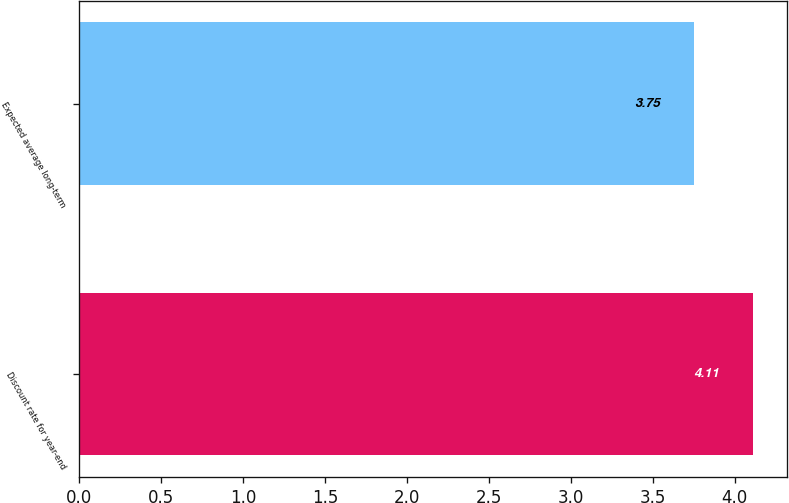Convert chart to OTSL. <chart><loc_0><loc_0><loc_500><loc_500><bar_chart><fcel>Discount rate for year-end<fcel>Expected average long-term<nl><fcel>4.11<fcel>3.75<nl></chart> 